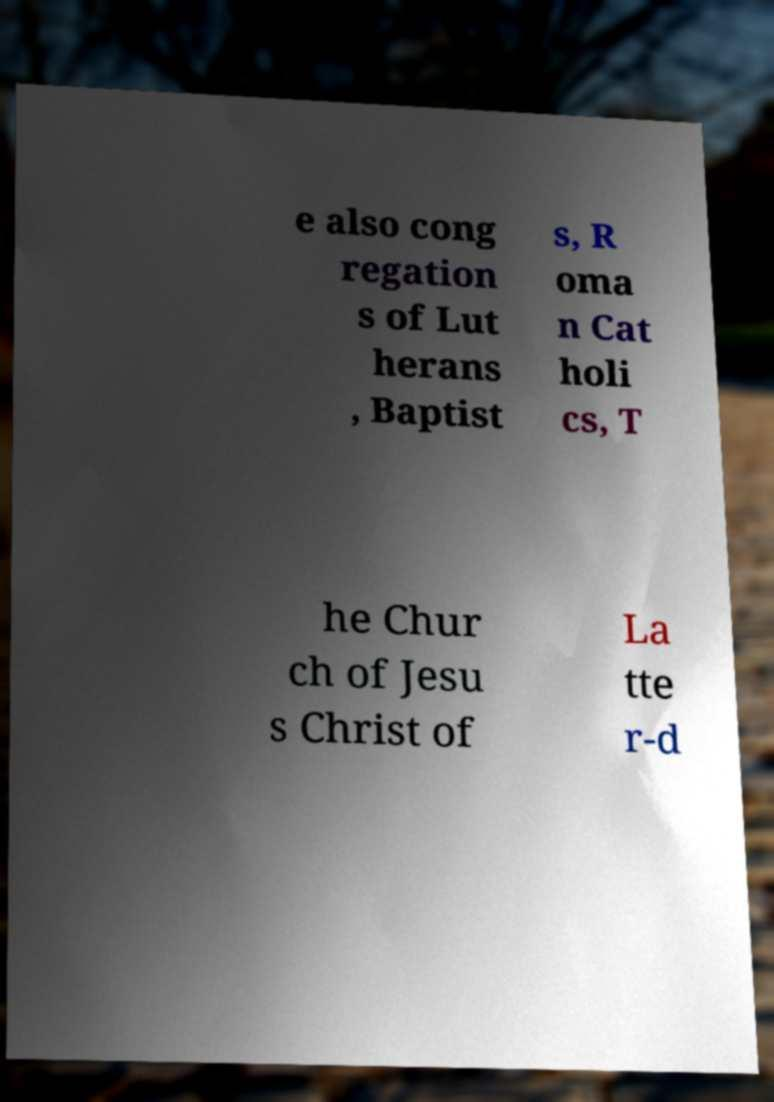Can you read and provide the text displayed in the image?This photo seems to have some interesting text. Can you extract and type it out for me? e also cong regation s of Lut herans , Baptist s, R oma n Cat holi cs, T he Chur ch of Jesu s Christ of La tte r-d 